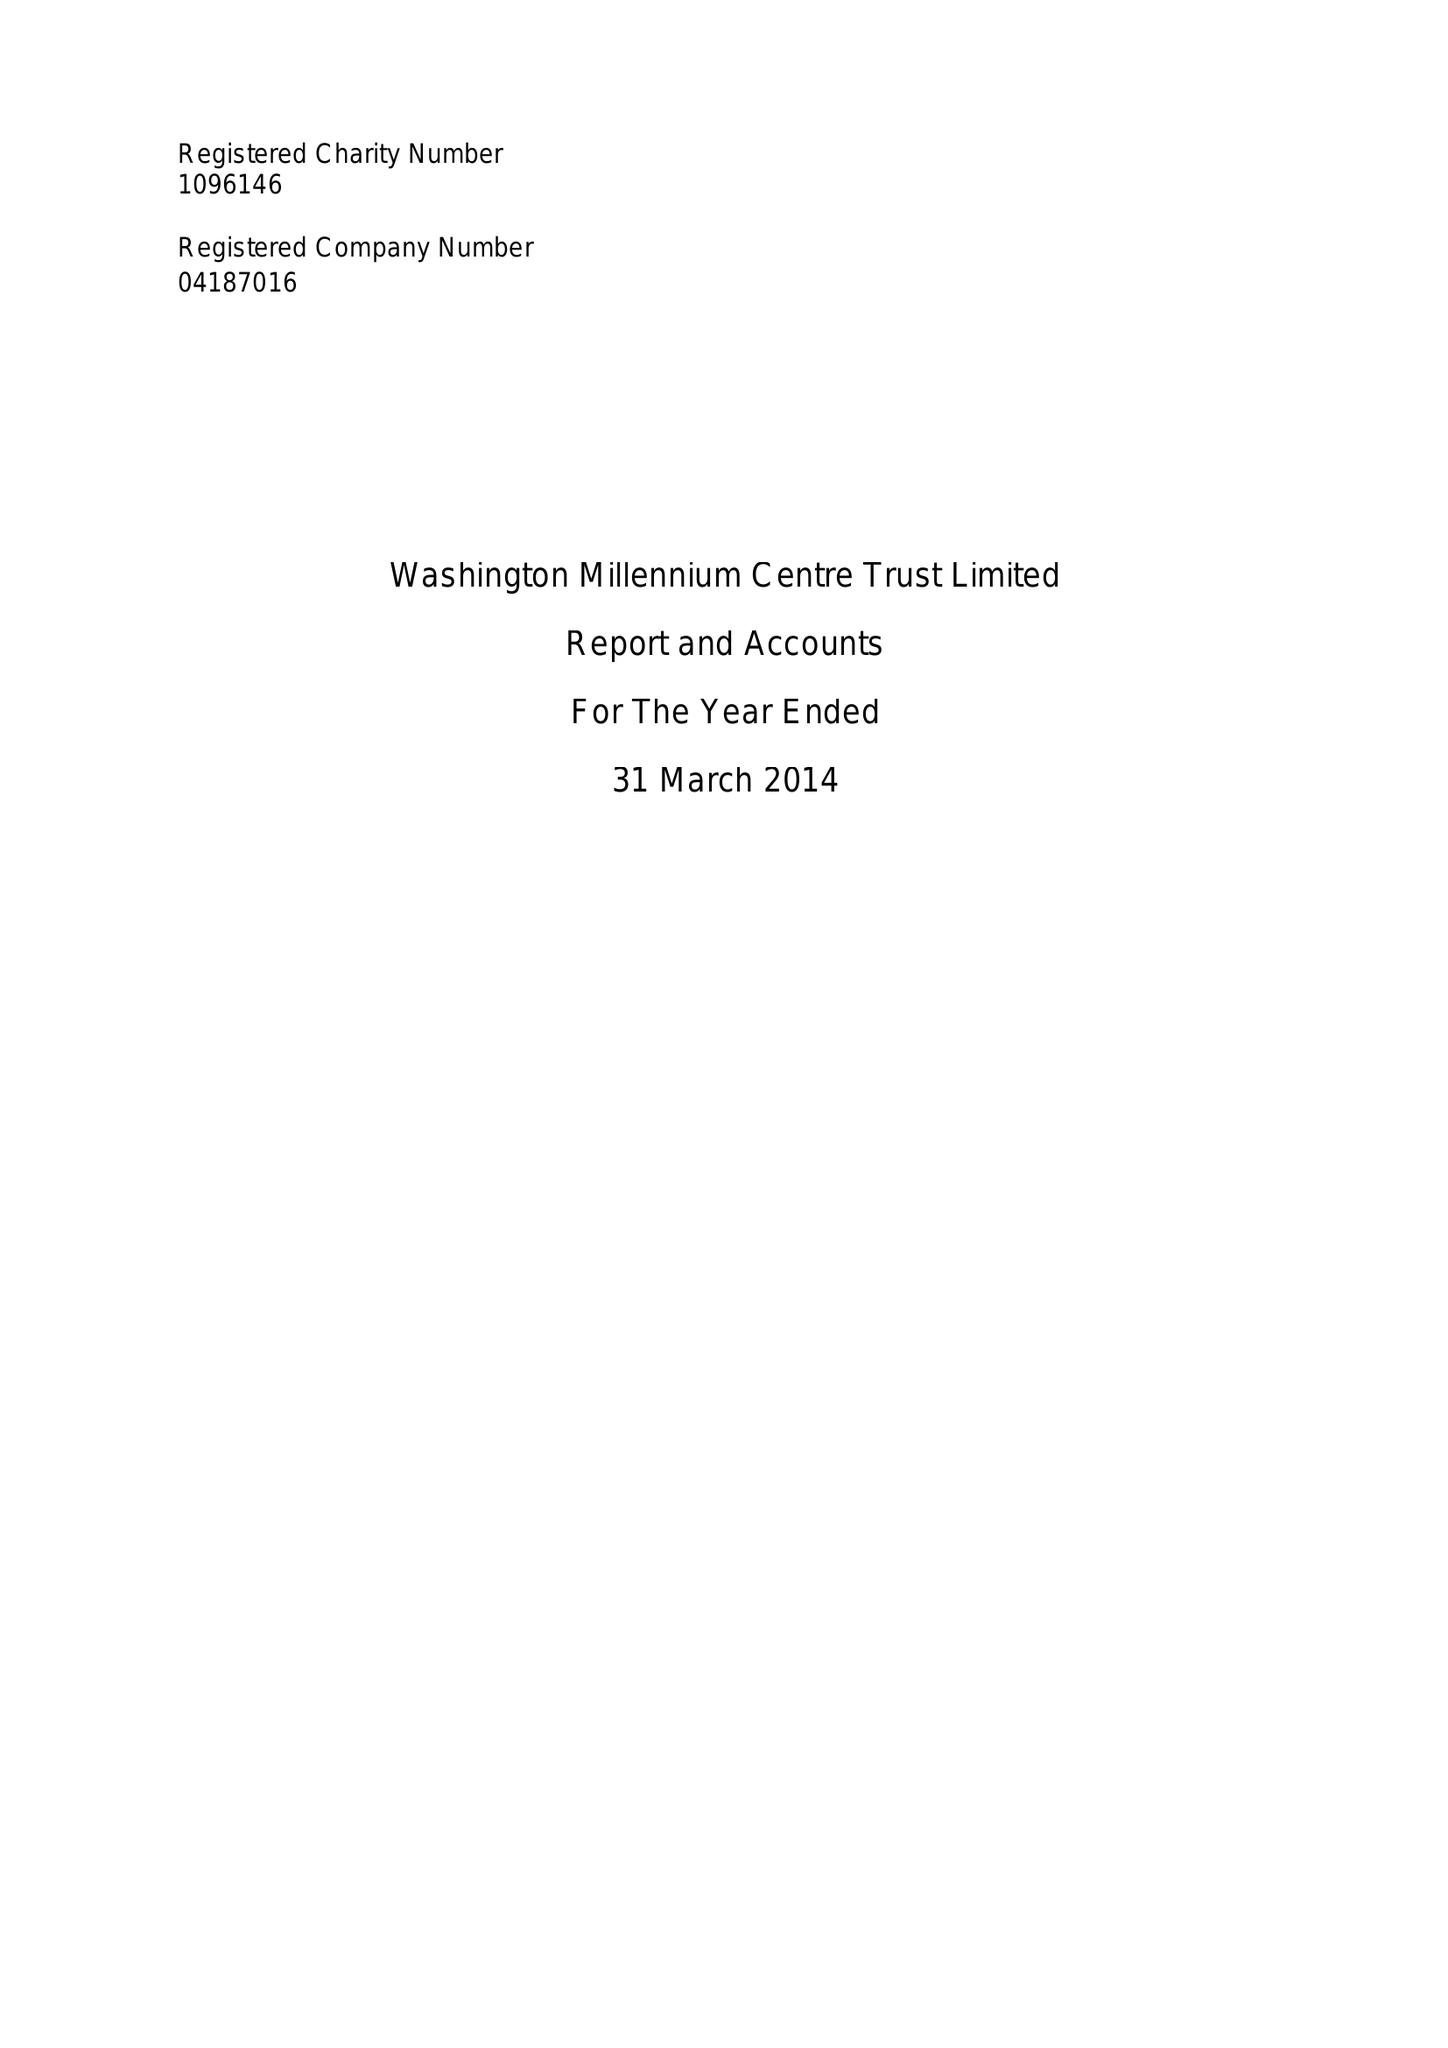What is the value for the address__post_town?
Answer the question using a single word or phrase. WASHINGTON 